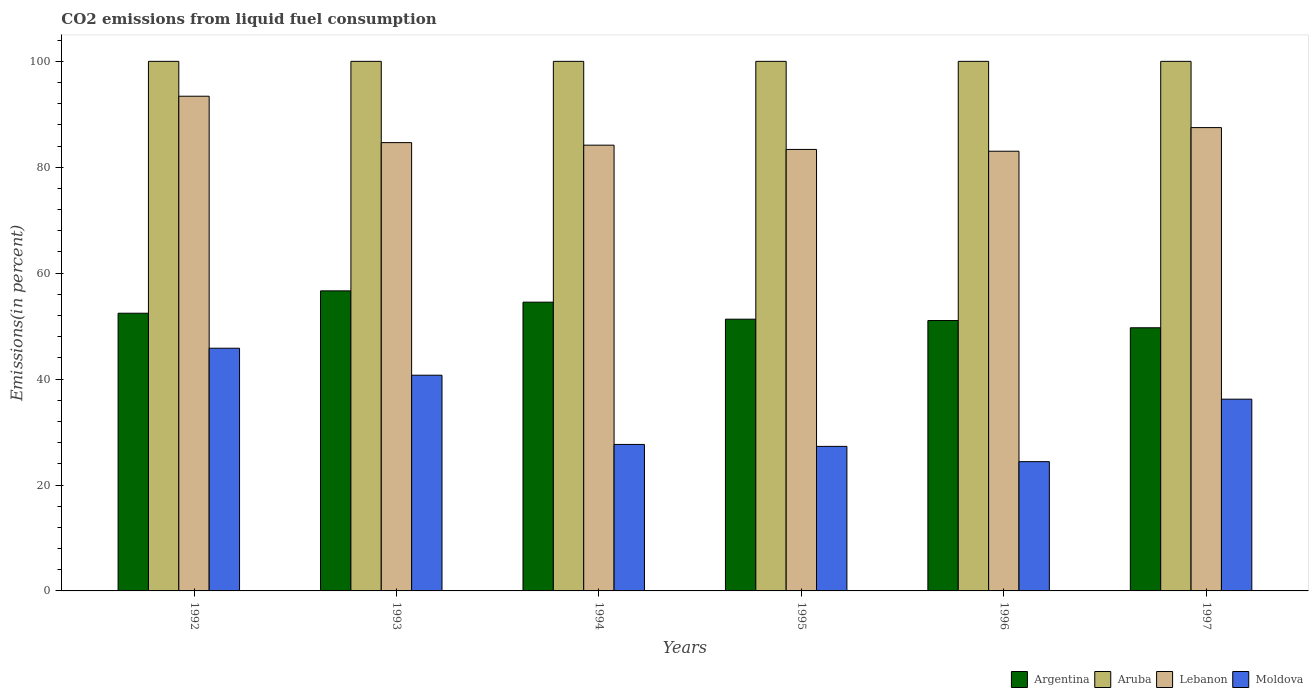How many different coloured bars are there?
Make the answer very short. 4. How many groups of bars are there?
Provide a short and direct response. 6. Are the number of bars per tick equal to the number of legend labels?
Your answer should be very brief. Yes. How many bars are there on the 1st tick from the left?
Provide a succinct answer. 4. How many bars are there on the 5th tick from the right?
Give a very brief answer. 4. What is the label of the 3rd group of bars from the left?
Offer a terse response. 1994. What is the total CO2 emitted in Argentina in 1992?
Your answer should be compact. 52.44. Across all years, what is the maximum total CO2 emitted in Argentina?
Offer a very short reply. 56.66. Across all years, what is the minimum total CO2 emitted in Lebanon?
Provide a short and direct response. 83.03. In which year was the total CO2 emitted in Moldova maximum?
Give a very brief answer. 1992. In which year was the total CO2 emitted in Argentina minimum?
Give a very brief answer. 1997. What is the total total CO2 emitted in Aruba in the graph?
Offer a very short reply. 600. What is the difference between the total CO2 emitted in Moldova in 1995 and that in 1996?
Your answer should be compact. 2.88. What is the difference between the total CO2 emitted in Argentina in 1996 and the total CO2 emitted in Aruba in 1994?
Your answer should be very brief. -48.94. What is the average total CO2 emitted in Lebanon per year?
Offer a terse response. 86.02. In the year 1997, what is the difference between the total CO2 emitted in Moldova and total CO2 emitted in Aruba?
Make the answer very short. -63.79. In how many years, is the total CO2 emitted in Aruba greater than 24 %?
Give a very brief answer. 6. What is the ratio of the total CO2 emitted in Moldova in 1995 to that in 1996?
Provide a succinct answer. 1.12. What is the difference between the highest and the second highest total CO2 emitted in Lebanon?
Your answer should be very brief. 5.92. What is the difference between the highest and the lowest total CO2 emitted in Moldova?
Provide a succinct answer. 21.42. What does the 3rd bar from the left in 1996 represents?
Provide a succinct answer. Lebanon. What does the 2nd bar from the right in 1997 represents?
Your answer should be very brief. Lebanon. How many years are there in the graph?
Make the answer very short. 6. Does the graph contain any zero values?
Keep it short and to the point. No. Where does the legend appear in the graph?
Your response must be concise. Bottom right. What is the title of the graph?
Keep it short and to the point. CO2 emissions from liquid fuel consumption. What is the label or title of the X-axis?
Your answer should be compact. Years. What is the label or title of the Y-axis?
Provide a short and direct response. Emissions(in percent). What is the Emissions(in percent) in Argentina in 1992?
Your answer should be very brief. 52.44. What is the Emissions(in percent) of Lebanon in 1992?
Make the answer very short. 93.42. What is the Emissions(in percent) in Moldova in 1992?
Provide a short and direct response. 45.83. What is the Emissions(in percent) of Argentina in 1993?
Offer a very short reply. 56.66. What is the Emissions(in percent) of Lebanon in 1993?
Your answer should be very brief. 84.65. What is the Emissions(in percent) of Moldova in 1993?
Make the answer very short. 40.73. What is the Emissions(in percent) of Argentina in 1994?
Give a very brief answer. 54.53. What is the Emissions(in percent) of Lebanon in 1994?
Give a very brief answer. 84.17. What is the Emissions(in percent) in Moldova in 1994?
Make the answer very short. 27.66. What is the Emissions(in percent) in Argentina in 1995?
Ensure brevity in your answer.  51.32. What is the Emissions(in percent) of Aruba in 1995?
Provide a succinct answer. 100. What is the Emissions(in percent) in Lebanon in 1995?
Your answer should be very brief. 83.37. What is the Emissions(in percent) in Moldova in 1995?
Offer a terse response. 27.29. What is the Emissions(in percent) of Argentina in 1996?
Offer a very short reply. 51.06. What is the Emissions(in percent) in Aruba in 1996?
Your response must be concise. 100. What is the Emissions(in percent) in Lebanon in 1996?
Your answer should be compact. 83.03. What is the Emissions(in percent) in Moldova in 1996?
Offer a very short reply. 24.41. What is the Emissions(in percent) of Argentina in 1997?
Offer a terse response. 49.69. What is the Emissions(in percent) in Aruba in 1997?
Offer a very short reply. 100. What is the Emissions(in percent) of Lebanon in 1997?
Make the answer very short. 87.49. What is the Emissions(in percent) in Moldova in 1997?
Your response must be concise. 36.21. Across all years, what is the maximum Emissions(in percent) of Argentina?
Offer a terse response. 56.66. Across all years, what is the maximum Emissions(in percent) of Lebanon?
Make the answer very short. 93.42. Across all years, what is the maximum Emissions(in percent) in Moldova?
Give a very brief answer. 45.83. Across all years, what is the minimum Emissions(in percent) in Argentina?
Your response must be concise. 49.69. Across all years, what is the minimum Emissions(in percent) in Lebanon?
Your answer should be very brief. 83.03. Across all years, what is the minimum Emissions(in percent) in Moldova?
Offer a terse response. 24.41. What is the total Emissions(in percent) in Argentina in the graph?
Provide a short and direct response. 315.69. What is the total Emissions(in percent) in Aruba in the graph?
Ensure brevity in your answer.  600. What is the total Emissions(in percent) in Lebanon in the graph?
Offer a terse response. 516.13. What is the total Emissions(in percent) of Moldova in the graph?
Offer a very short reply. 202.14. What is the difference between the Emissions(in percent) in Argentina in 1992 and that in 1993?
Offer a very short reply. -4.22. What is the difference between the Emissions(in percent) in Lebanon in 1992 and that in 1993?
Your answer should be very brief. 8.76. What is the difference between the Emissions(in percent) of Moldova in 1992 and that in 1993?
Your answer should be very brief. 5.1. What is the difference between the Emissions(in percent) in Argentina in 1992 and that in 1994?
Your answer should be very brief. -2.09. What is the difference between the Emissions(in percent) of Lebanon in 1992 and that in 1994?
Your answer should be very brief. 9.24. What is the difference between the Emissions(in percent) in Moldova in 1992 and that in 1994?
Your answer should be compact. 18.17. What is the difference between the Emissions(in percent) of Argentina in 1992 and that in 1995?
Offer a very short reply. 1.12. What is the difference between the Emissions(in percent) of Lebanon in 1992 and that in 1995?
Your answer should be compact. 10.05. What is the difference between the Emissions(in percent) in Moldova in 1992 and that in 1995?
Make the answer very short. 18.54. What is the difference between the Emissions(in percent) of Argentina in 1992 and that in 1996?
Provide a succinct answer. 1.38. What is the difference between the Emissions(in percent) in Aruba in 1992 and that in 1996?
Your answer should be compact. 0. What is the difference between the Emissions(in percent) of Lebanon in 1992 and that in 1996?
Provide a short and direct response. 10.39. What is the difference between the Emissions(in percent) in Moldova in 1992 and that in 1996?
Your response must be concise. 21.42. What is the difference between the Emissions(in percent) in Argentina in 1992 and that in 1997?
Offer a terse response. 2.75. What is the difference between the Emissions(in percent) of Aruba in 1992 and that in 1997?
Ensure brevity in your answer.  0. What is the difference between the Emissions(in percent) of Lebanon in 1992 and that in 1997?
Make the answer very short. 5.92. What is the difference between the Emissions(in percent) of Moldova in 1992 and that in 1997?
Ensure brevity in your answer.  9.62. What is the difference between the Emissions(in percent) in Argentina in 1993 and that in 1994?
Your response must be concise. 2.13. What is the difference between the Emissions(in percent) of Aruba in 1993 and that in 1994?
Provide a short and direct response. 0. What is the difference between the Emissions(in percent) of Lebanon in 1993 and that in 1994?
Your response must be concise. 0.48. What is the difference between the Emissions(in percent) of Moldova in 1993 and that in 1994?
Keep it short and to the point. 13.07. What is the difference between the Emissions(in percent) of Argentina in 1993 and that in 1995?
Keep it short and to the point. 5.35. What is the difference between the Emissions(in percent) of Aruba in 1993 and that in 1995?
Your answer should be compact. 0. What is the difference between the Emissions(in percent) in Lebanon in 1993 and that in 1995?
Your response must be concise. 1.28. What is the difference between the Emissions(in percent) in Moldova in 1993 and that in 1995?
Give a very brief answer. 13.44. What is the difference between the Emissions(in percent) of Argentina in 1993 and that in 1996?
Your answer should be very brief. 5.6. What is the difference between the Emissions(in percent) in Aruba in 1993 and that in 1996?
Provide a short and direct response. 0. What is the difference between the Emissions(in percent) of Lebanon in 1993 and that in 1996?
Give a very brief answer. 1.63. What is the difference between the Emissions(in percent) of Moldova in 1993 and that in 1996?
Keep it short and to the point. 16.32. What is the difference between the Emissions(in percent) of Argentina in 1993 and that in 1997?
Give a very brief answer. 6.97. What is the difference between the Emissions(in percent) in Aruba in 1993 and that in 1997?
Give a very brief answer. 0. What is the difference between the Emissions(in percent) in Lebanon in 1993 and that in 1997?
Your response must be concise. -2.84. What is the difference between the Emissions(in percent) in Moldova in 1993 and that in 1997?
Make the answer very short. 4.52. What is the difference between the Emissions(in percent) in Argentina in 1994 and that in 1995?
Offer a very short reply. 3.21. What is the difference between the Emissions(in percent) of Lebanon in 1994 and that in 1995?
Your answer should be compact. 0.8. What is the difference between the Emissions(in percent) of Moldova in 1994 and that in 1995?
Your answer should be very brief. 0.37. What is the difference between the Emissions(in percent) in Argentina in 1994 and that in 1996?
Make the answer very short. 3.47. What is the difference between the Emissions(in percent) of Aruba in 1994 and that in 1996?
Keep it short and to the point. 0. What is the difference between the Emissions(in percent) in Lebanon in 1994 and that in 1996?
Keep it short and to the point. 1.14. What is the difference between the Emissions(in percent) of Moldova in 1994 and that in 1996?
Give a very brief answer. 3.25. What is the difference between the Emissions(in percent) of Argentina in 1994 and that in 1997?
Your response must be concise. 4.84. What is the difference between the Emissions(in percent) in Aruba in 1994 and that in 1997?
Give a very brief answer. 0. What is the difference between the Emissions(in percent) in Lebanon in 1994 and that in 1997?
Offer a terse response. -3.32. What is the difference between the Emissions(in percent) in Moldova in 1994 and that in 1997?
Your answer should be very brief. -8.55. What is the difference between the Emissions(in percent) of Argentina in 1995 and that in 1996?
Ensure brevity in your answer.  0.26. What is the difference between the Emissions(in percent) of Lebanon in 1995 and that in 1996?
Offer a very short reply. 0.34. What is the difference between the Emissions(in percent) in Moldova in 1995 and that in 1996?
Make the answer very short. 2.88. What is the difference between the Emissions(in percent) in Argentina in 1995 and that in 1997?
Offer a very short reply. 1.62. What is the difference between the Emissions(in percent) of Aruba in 1995 and that in 1997?
Your answer should be very brief. 0. What is the difference between the Emissions(in percent) in Lebanon in 1995 and that in 1997?
Your answer should be compact. -4.12. What is the difference between the Emissions(in percent) of Moldova in 1995 and that in 1997?
Your answer should be compact. -8.92. What is the difference between the Emissions(in percent) in Argentina in 1996 and that in 1997?
Provide a succinct answer. 1.37. What is the difference between the Emissions(in percent) of Lebanon in 1996 and that in 1997?
Your response must be concise. -4.46. What is the difference between the Emissions(in percent) in Moldova in 1996 and that in 1997?
Your answer should be compact. -11.8. What is the difference between the Emissions(in percent) in Argentina in 1992 and the Emissions(in percent) in Aruba in 1993?
Give a very brief answer. -47.56. What is the difference between the Emissions(in percent) of Argentina in 1992 and the Emissions(in percent) of Lebanon in 1993?
Offer a terse response. -32.22. What is the difference between the Emissions(in percent) in Argentina in 1992 and the Emissions(in percent) in Moldova in 1993?
Your answer should be very brief. 11.71. What is the difference between the Emissions(in percent) in Aruba in 1992 and the Emissions(in percent) in Lebanon in 1993?
Make the answer very short. 15.35. What is the difference between the Emissions(in percent) in Aruba in 1992 and the Emissions(in percent) in Moldova in 1993?
Your answer should be compact. 59.27. What is the difference between the Emissions(in percent) in Lebanon in 1992 and the Emissions(in percent) in Moldova in 1993?
Your response must be concise. 52.68. What is the difference between the Emissions(in percent) of Argentina in 1992 and the Emissions(in percent) of Aruba in 1994?
Your answer should be compact. -47.56. What is the difference between the Emissions(in percent) of Argentina in 1992 and the Emissions(in percent) of Lebanon in 1994?
Provide a succinct answer. -31.73. What is the difference between the Emissions(in percent) in Argentina in 1992 and the Emissions(in percent) in Moldova in 1994?
Your response must be concise. 24.78. What is the difference between the Emissions(in percent) of Aruba in 1992 and the Emissions(in percent) of Lebanon in 1994?
Your answer should be very brief. 15.83. What is the difference between the Emissions(in percent) in Aruba in 1992 and the Emissions(in percent) in Moldova in 1994?
Your answer should be very brief. 72.34. What is the difference between the Emissions(in percent) in Lebanon in 1992 and the Emissions(in percent) in Moldova in 1994?
Your answer should be very brief. 65.75. What is the difference between the Emissions(in percent) of Argentina in 1992 and the Emissions(in percent) of Aruba in 1995?
Your response must be concise. -47.56. What is the difference between the Emissions(in percent) in Argentina in 1992 and the Emissions(in percent) in Lebanon in 1995?
Ensure brevity in your answer.  -30.93. What is the difference between the Emissions(in percent) of Argentina in 1992 and the Emissions(in percent) of Moldova in 1995?
Your answer should be very brief. 25.14. What is the difference between the Emissions(in percent) in Aruba in 1992 and the Emissions(in percent) in Lebanon in 1995?
Provide a short and direct response. 16.63. What is the difference between the Emissions(in percent) of Aruba in 1992 and the Emissions(in percent) of Moldova in 1995?
Make the answer very short. 72.71. What is the difference between the Emissions(in percent) of Lebanon in 1992 and the Emissions(in percent) of Moldova in 1995?
Provide a succinct answer. 66.12. What is the difference between the Emissions(in percent) in Argentina in 1992 and the Emissions(in percent) in Aruba in 1996?
Make the answer very short. -47.56. What is the difference between the Emissions(in percent) of Argentina in 1992 and the Emissions(in percent) of Lebanon in 1996?
Offer a terse response. -30.59. What is the difference between the Emissions(in percent) of Argentina in 1992 and the Emissions(in percent) of Moldova in 1996?
Provide a short and direct response. 28.03. What is the difference between the Emissions(in percent) of Aruba in 1992 and the Emissions(in percent) of Lebanon in 1996?
Give a very brief answer. 16.97. What is the difference between the Emissions(in percent) of Aruba in 1992 and the Emissions(in percent) of Moldova in 1996?
Give a very brief answer. 75.59. What is the difference between the Emissions(in percent) in Lebanon in 1992 and the Emissions(in percent) in Moldova in 1996?
Your answer should be compact. 69. What is the difference between the Emissions(in percent) of Argentina in 1992 and the Emissions(in percent) of Aruba in 1997?
Your response must be concise. -47.56. What is the difference between the Emissions(in percent) in Argentina in 1992 and the Emissions(in percent) in Lebanon in 1997?
Provide a short and direct response. -35.05. What is the difference between the Emissions(in percent) of Argentina in 1992 and the Emissions(in percent) of Moldova in 1997?
Keep it short and to the point. 16.23. What is the difference between the Emissions(in percent) in Aruba in 1992 and the Emissions(in percent) in Lebanon in 1997?
Offer a very short reply. 12.51. What is the difference between the Emissions(in percent) of Aruba in 1992 and the Emissions(in percent) of Moldova in 1997?
Offer a terse response. 63.79. What is the difference between the Emissions(in percent) in Lebanon in 1992 and the Emissions(in percent) in Moldova in 1997?
Ensure brevity in your answer.  57.21. What is the difference between the Emissions(in percent) of Argentina in 1993 and the Emissions(in percent) of Aruba in 1994?
Your answer should be very brief. -43.34. What is the difference between the Emissions(in percent) of Argentina in 1993 and the Emissions(in percent) of Lebanon in 1994?
Your answer should be compact. -27.51. What is the difference between the Emissions(in percent) in Argentina in 1993 and the Emissions(in percent) in Moldova in 1994?
Keep it short and to the point. 29. What is the difference between the Emissions(in percent) of Aruba in 1993 and the Emissions(in percent) of Lebanon in 1994?
Make the answer very short. 15.83. What is the difference between the Emissions(in percent) in Aruba in 1993 and the Emissions(in percent) in Moldova in 1994?
Make the answer very short. 72.34. What is the difference between the Emissions(in percent) of Lebanon in 1993 and the Emissions(in percent) of Moldova in 1994?
Provide a short and direct response. 56.99. What is the difference between the Emissions(in percent) of Argentina in 1993 and the Emissions(in percent) of Aruba in 1995?
Keep it short and to the point. -43.34. What is the difference between the Emissions(in percent) in Argentina in 1993 and the Emissions(in percent) in Lebanon in 1995?
Your answer should be compact. -26.71. What is the difference between the Emissions(in percent) in Argentina in 1993 and the Emissions(in percent) in Moldova in 1995?
Make the answer very short. 29.37. What is the difference between the Emissions(in percent) of Aruba in 1993 and the Emissions(in percent) of Lebanon in 1995?
Offer a very short reply. 16.63. What is the difference between the Emissions(in percent) of Aruba in 1993 and the Emissions(in percent) of Moldova in 1995?
Your response must be concise. 72.71. What is the difference between the Emissions(in percent) of Lebanon in 1993 and the Emissions(in percent) of Moldova in 1995?
Offer a terse response. 57.36. What is the difference between the Emissions(in percent) in Argentina in 1993 and the Emissions(in percent) in Aruba in 1996?
Your answer should be compact. -43.34. What is the difference between the Emissions(in percent) in Argentina in 1993 and the Emissions(in percent) in Lebanon in 1996?
Ensure brevity in your answer.  -26.37. What is the difference between the Emissions(in percent) of Argentina in 1993 and the Emissions(in percent) of Moldova in 1996?
Provide a succinct answer. 32.25. What is the difference between the Emissions(in percent) of Aruba in 1993 and the Emissions(in percent) of Lebanon in 1996?
Make the answer very short. 16.97. What is the difference between the Emissions(in percent) in Aruba in 1993 and the Emissions(in percent) in Moldova in 1996?
Your answer should be very brief. 75.59. What is the difference between the Emissions(in percent) in Lebanon in 1993 and the Emissions(in percent) in Moldova in 1996?
Make the answer very short. 60.24. What is the difference between the Emissions(in percent) in Argentina in 1993 and the Emissions(in percent) in Aruba in 1997?
Provide a short and direct response. -43.34. What is the difference between the Emissions(in percent) of Argentina in 1993 and the Emissions(in percent) of Lebanon in 1997?
Offer a very short reply. -30.83. What is the difference between the Emissions(in percent) of Argentina in 1993 and the Emissions(in percent) of Moldova in 1997?
Give a very brief answer. 20.45. What is the difference between the Emissions(in percent) in Aruba in 1993 and the Emissions(in percent) in Lebanon in 1997?
Provide a short and direct response. 12.51. What is the difference between the Emissions(in percent) of Aruba in 1993 and the Emissions(in percent) of Moldova in 1997?
Provide a succinct answer. 63.79. What is the difference between the Emissions(in percent) in Lebanon in 1993 and the Emissions(in percent) in Moldova in 1997?
Your response must be concise. 48.45. What is the difference between the Emissions(in percent) in Argentina in 1994 and the Emissions(in percent) in Aruba in 1995?
Your response must be concise. -45.47. What is the difference between the Emissions(in percent) in Argentina in 1994 and the Emissions(in percent) in Lebanon in 1995?
Provide a succinct answer. -28.84. What is the difference between the Emissions(in percent) in Argentina in 1994 and the Emissions(in percent) in Moldova in 1995?
Provide a succinct answer. 27.23. What is the difference between the Emissions(in percent) of Aruba in 1994 and the Emissions(in percent) of Lebanon in 1995?
Your answer should be compact. 16.63. What is the difference between the Emissions(in percent) of Aruba in 1994 and the Emissions(in percent) of Moldova in 1995?
Provide a succinct answer. 72.71. What is the difference between the Emissions(in percent) of Lebanon in 1994 and the Emissions(in percent) of Moldova in 1995?
Provide a succinct answer. 56.88. What is the difference between the Emissions(in percent) of Argentina in 1994 and the Emissions(in percent) of Aruba in 1996?
Keep it short and to the point. -45.47. What is the difference between the Emissions(in percent) of Argentina in 1994 and the Emissions(in percent) of Lebanon in 1996?
Ensure brevity in your answer.  -28.5. What is the difference between the Emissions(in percent) of Argentina in 1994 and the Emissions(in percent) of Moldova in 1996?
Ensure brevity in your answer.  30.12. What is the difference between the Emissions(in percent) in Aruba in 1994 and the Emissions(in percent) in Lebanon in 1996?
Keep it short and to the point. 16.97. What is the difference between the Emissions(in percent) in Aruba in 1994 and the Emissions(in percent) in Moldova in 1996?
Provide a succinct answer. 75.59. What is the difference between the Emissions(in percent) of Lebanon in 1994 and the Emissions(in percent) of Moldova in 1996?
Your response must be concise. 59.76. What is the difference between the Emissions(in percent) of Argentina in 1994 and the Emissions(in percent) of Aruba in 1997?
Your response must be concise. -45.47. What is the difference between the Emissions(in percent) in Argentina in 1994 and the Emissions(in percent) in Lebanon in 1997?
Keep it short and to the point. -32.96. What is the difference between the Emissions(in percent) of Argentina in 1994 and the Emissions(in percent) of Moldova in 1997?
Keep it short and to the point. 18.32. What is the difference between the Emissions(in percent) of Aruba in 1994 and the Emissions(in percent) of Lebanon in 1997?
Ensure brevity in your answer.  12.51. What is the difference between the Emissions(in percent) of Aruba in 1994 and the Emissions(in percent) of Moldova in 1997?
Offer a very short reply. 63.79. What is the difference between the Emissions(in percent) of Lebanon in 1994 and the Emissions(in percent) of Moldova in 1997?
Keep it short and to the point. 47.96. What is the difference between the Emissions(in percent) of Argentina in 1995 and the Emissions(in percent) of Aruba in 1996?
Keep it short and to the point. -48.68. What is the difference between the Emissions(in percent) in Argentina in 1995 and the Emissions(in percent) in Lebanon in 1996?
Provide a succinct answer. -31.71. What is the difference between the Emissions(in percent) of Argentina in 1995 and the Emissions(in percent) of Moldova in 1996?
Provide a succinct answer. 26.9. What is the difference between the Emissions(in percent) in Aruba in 1995 and the Emissions(in percent) in Lebanon in 1996?
Make the answer very short. 16.97. What is the difference between the Emissions(in percent) of Aruba in 1995 and the Emissions(in percent) of Moldova in 1996?
Your answer should be very brief. 75.59. What is the difference between the Emissions(in percent) in Lebanon in 1995 and the Emissions(in percent) in Moldova in 1996?
Give a very brief answer. 58.96. What is the difference between the Emissions(in percent) of Argentina in 1995 and the Emissions(in percent) of Aruba in 1997?
Offer a terse response. -48.68. What is the difference between the Emissions(in percent) in Argentina in 1995 and the Emissions(in percent) in Lebanon in 1997?
Keep it short and to the point. -36.18. What is the difference between the Emissions(in percent) in Argentina in 1995 and the Emissions(in percent) in Moldova in 1997?
Give a very brief answer. 15.11. What is the difference between the Emissions(in percent) of Aruba in 1995 and the Emissions(in percent) of Lebanon in 1997?
Make the answer very short. 12.51. What is the difference between the Emissions(in percent) of Aruba in 1995 and the Emissions(in percent) of Moldova in 1997?
Offer a terse response. 63.79. What is the difference between the Emissions(in percent) in Lebanon in 1995 and the Emissions(in percent) in Moldova in 1997?
Ensure brevity in your answer.  47.16. What is the difference between the Emissions(in percent) of Argentina in 1996 and the Emissions(in percent) of Aruba in 1997?
Your response must be concise. -48.94. What is the difference between the Emissions(in percent) in Argentina in 1996 and the Emissions(in percent) in Lebanon in 1997?
Make the answer very short. -36.43. What is the difference between the Emissions(in percent) in Argentina in 1996 and the Emissions(in percent) in Moldova in 1997?
Offer a very short reply. 14.85. What is the difference between the Emissions(in percent) of Aruba in 1996 and the Emissions(in percent) of Lebanon in 1997?
Your response must be concise. 12.51. What is the difference between the Emissions(in percent) of Aruba in 1996 and the Emissions(in percent) of Moldova in 1997?
Make the answer very short. 63.79. What is the difference between the Emissions(in percent) in Lebanon in 1996 and the Emissions(in percent) in Moldova in 1997?
Give a very brief answer. 46.82. What is the average Emissions(in percent) in Argentina per year?
Offer a terse response. 52.62. What is the average Emissions(in percent) in Aruba per year?
Your response must be concise. 100. What is the average Emissions(in percent) in Lebanon per year?
Give a very brief answer. 86.02. What is the average Emissions(in percent) in Moldova per year?
Provide a succinct answer. 33.69. In the year 1992, what is the difference between the Emissions(in percent) in Argentina and Emissions(in percent) in Aruba?
Give a very brief answer. -47.56. In the year 1992, what is the difference between the Emissions(in percent) of Argentina and Emissions(in percent) of Lebanon?
Make the answer very short. -40.98. In the year 1992, what is the difference between the Emissions(in percent) in Argentina and Emissions(in percent) in Moldova?
Provide a short and direct response. 6.61. In the year 1992, what is the difference between the Emissions(in percent) in Aruba and Emissions(in percent) in Lebanon?
Keep it short and to the point. 6.58. In the year 1992, what is the difference between the Emissions(in percent) in Aruba and Emissions(in percent) in Moldova?
Your answer should be very brief. 54.17. In the year 1992, what is the difference between the Emissions(in percent) of Lebanon and Emissions(in percent) of Moldova?
Provide a short and direct response. 47.59. In the year 1993, what is the difference between the Emissions(in percent) of Argentina and Emissions(in percent) of Aruba?
Provide a succinct answer. -43.34. In the year 1993, what is the difference between the Emissions(in percent) of Argentina and Emissions(in percent) of Lebanon?
Your answer should be compact. -27.99. In the year 1993, what is the difference between the Emissions(in percent) of Argentina and Emissions(in percent) of Moldova?
Keep it short and to the point. 15.93. In the year 1993, what is the difference between the Emissions(in percent) of Aruba and Emissions(in percent) of Lebanon?
Offer a terse response. 15.35. In the year 1993, what is the difference between the Emissions(in percent) of Aruba and Emissions(in percent) of Moldova?
Offer a terse response. 59.27. In the year 1993, what is the difference between the Emissions(in percent) in Lebanon and Emissions(in percent) in Moldova?
Provide a short and direct response. 43.92. In the year 1994, what is the difference between the Emissions(in percent) in Argentina and Emissions(in percent) in Aruba?
Provide a succinct answer. -45.47. In the year 1994, what is the difference between the Emissions(in percent) in Argentina and Emissions(in percent) in Lebanon?
Offer a terse response. -29.64. In the year 1994, what is the difference between the Emissions(in percent) in Argentina and Emissions(in percent) in Moldova?
Provide a succinct answer. 26.87. In the year 1994, what is the difference between the Emissions(in percent) in Aruba and Emissions(in percent) in Lebanon?
Make the answer very short. 15.83. In the year 1994, what is the difference between the Emissions(in percent) in Aruba and Emissions(in percent) in Moldova?
Your answer should be compact. 72.34. In the year 1994, what is the difference between the Emissions(in percent) of Lebanon and Emissions(in percent) of Moldova?
Give a very brief answer. 56.51. In the year 1995, what is the difference between the Emissions(in percent) in Argentina and Emissions(in percent) in Aruba?
Ensure brevity in your answer.  -48.68. In the year 1995, what is the difference between the Emissions(in percent) of Argentina and Emissions(in percent) of Lebanon?
Provide a short and direct response. -32.05. In the year 1995, what is the difference between the Emissions(in percent) in Argentina and Emissions(in percent) in Moldova?
Give a very brief answer. 24.02. In the year 1995, what is the difference between the Emissions(in percent) of Aruba and Emissions(in percent) of Lebanon?
Your response must be concise. 16.63. In the year 1995, what is the difference between the Emissions(in percent) of Aruba and Emissions(in percent) of Moldova?
Ensure brevity in your answer.  72.71. In the year 1995, what is the difference between the Emissions(in percent) of Lebanon and Emissions(in percent) of Moldova?
Give a very brief answer. 56.08. In the year 1996, what is the difference between the Emissions(in percent) of Argentina and Emissions(in percent) of Aruba?
Provide a succinct answer. -48.94. In the year 1996, what is the difference between the Emissions(in percent) of Argentina and Emissions(in percent) of Lebanon?
Ensure brevity in your answer.  -31.97. In the year 1996, what is the difference between the Emissions(in percent) in Argentina and Emissions(in percent) in Moldova?
Provide a short and direct response. 26.65. In the year 1996, what is the difference between the Emissions(in percent) in Aruba and Emissions(in percent) in Lebanon?
Offer a very short reply. 16.97. In the year 1996, what is the difference between the Emissions(in percent) of Aruba and Emissions(in percent) of Moldova?
Offer a very short reply. 75.59. In the year 1996, what is the difference between the Emissions(in percent) of Lebanon and Emissions(in percent) of Moldova?
Your response must be concise. 58.62. In the year 1997, what is the difference between the Emissions(in percent) in Argentina and Emissions(in percent) in Aruba?
Provide a short and direct response. -50.31. In the year 1997, what is the difference between the Emissions(in percent) of Argentina and Emissions(in percent) of Lebanon?
Ensure brevity in your answer.  -37.8. In the year 1997, what is the difference between the Emissions(in percent) in Argentina and Emissions(in percent) in Moldova?
Offer a terse response. 13.48. In the year 1997, what is the difference between the Emissions(in percent) in Aruba and Emissions(in percent) in Lebanon?
Provide a short and direct response. 12.51. In the year 1997, what is the difference between the Emissions(in percent) of Aruba and Emissions(in percent) of Moldova?
Give a very brief answer. 63.79. In the year 1997, what is the difference between the Emissions(in percent) of Lebanon and Emissions(in percent) of Moldova?
Your response must be concise. 51.28. What is the ratio of the Emissions(in percent) of Argentina in 1992 to that in 1993?
Keep it short and to the point. 0.93. What is the ratio of the Emissions(in percent) of Lebanon in 1992 to that in 1993?
Your answer should be very brief. 1.1. What is the ratio of the Emissions(in percent) of Moldova in 1992 to that in 1993?
Offer a very short reply. 1.13. What is the ratio of the Emissions(in percent) in Argentina in 1992 to that in 1994?
Offer a terse response. 0.96. What is the ratio of the Emissions(in percent) in Lebanon in 1992 to that in 1994?
Your answer should be very brief. 1.11. What is the ratio of the Emissions(in percent) in Moldova in 1992 to that in 1994?
Your response must be concise. 1.66. What is the ratio of the Emissions(in percent) of Argentina in 1992 to that in 1995?
Your answer should be compact. 1.02. What is the ratio of the Emissions(in percent) in Lebanon in 1992 to that in 1995?
Offer a terse response. 1.12. What is the ratio of the Emissions(in percent) of Moldova in 1992 to that in 1995?
Give a very brief answer. 1.68. What is the ratio of the Emissions(in percent) in Lebanon in 1992 to that in 1996?
Offer a very short reply. 1.13. What is the ratio of the Emissions(in percent) of Moldova in 1992 to that in 1996?
Provide a succinct answer. 1.88. What is the ratio of the Emissions(in percent) of Argentina in 1992 to that in 1997?
Offer a terse response. 1.06. What is the ratio of the Emissions(in percent) in Aruba in 1992 to that in 1997?
Give a very brief answer. 1. What is the ratio of the Emissions(in percent) of Lebanon in 1992 to that in 1997?
Give a very brief answer. 1.07. What is the ratio of the Emissions(in percent) of Moldova in 1992 to that in 1997?
Make the answer very short. 1.27. What is the ratio of the Emissions(in percent) in Argentina in 1993 to that in 1994?
Offer a terse response. 1.04. What is the ratio of the Emissions(in percent) in Aruba in 1993 to that in 1994?
Your response must be concise. 1. What is the ratio of the Emissions(in percent) of Lebanon in 1993 to that in 1994?
Provide a succinct answer. 1.01. What is the ratio of the Emissions(in percent) in Moldova in 1993 to that in 1994?
Provide a short and direct response. 1.47. What is the ratio of the Emissions(in percent) in Argentina in 1993 to that in 1995?
Make the answer very short. 1.1. What is the ratio of the Emissions(in percent) in Aruba in 1993 to that in 1995?
Provide a short and direct response. 1. What is the ratio of the Emissions(in percent) of Lebanon in 1993 to that in 1995?
Offer a very short reply. 1.02. What is the ratio of the Emissions(in percent) in Moldova in 1993 to that in 1995?
Make the answer very short. 1.49. What is the ratio of the Emissions(in percent) of Argentina in 1993 to that in 1996?
Provide a short and direct response. 1.11. What is the ratio of the Emissions(in percent) of Lebanon in 1993 to that in 1996?
Provide a short and direct response. 1.02. What is the ratio of the Emissions(in percent) in Moldova in 1993 to that in 1996?
Ensure brevity in your answer.  1.67. What is the ratio of the Emissions(in percent) of Argentina in 1993 to that in 1997?
Make the answer very short. 1.14. What is the ratio of the Emissions(in percent) in Aruba in 1993 to that in 1997?
Provide a short and direct response. 1. What is the ratio of the Emissions(in percent) in Lebanon in 1993 to that in 1997?
Offer a very short reply. 0.97. What is the ratio of the Emissions(in percent) in Moldova in 1993 to that in 1997?
Make the answer very short. 1.12. What is the ratio of the Emissions(in percent) in Argentina in 1994 to that in 1995?
Your answer should be very brief. 1.06. What is the ratio of the Emissions(in percent) of Aruba in 1994 to that in 1995?
Ensure brevity in your answer.  1. What is the ratio of the Emissions(in percent) of Lebanon in 1994 to that in 1995?
Your response must be concise. 1.01. What is the ratio of the Emissions(in percent) in Moldova in 1994 to that in 1995?
Offer a terse response. 1.01. What is the ratio of the Emissions(in percent) of Argentina in 1994 to that in 1996?
Keep it short and to the point. 1.07. What is the ratio of the Emissions(in percent) of Aruba in 1994 to that in 1996?
Offer a terse response. 1. What is the ratio of the Emissions(in percent) of Lebanon in 1994 to that in 1996?
Offer a very short reply. 1.01. What is the ratio of the Emissions(in percent) in Moldova in 1994 to that in 1996?
Your response must be concise. 1.13. What is the ratio of the Emissions(in percent) in Argentina in 1994 to that in 1997?
Provide a succinct answer. 1.1. What is the ratio of the Emissions(in percent) of Lebanon in 1994 to that in 1997?
Your answer should be very brief. 0.96. What is the ratio of the Emissions(in percent) of Moldova in 1994 to that in 1997?
Your answer should be very brief. 0.76. What is the ratio of the Emissions(in percent) in Aruba in 1995 to that in 1996?
Your answer should be very brief. 1. What is the ratio of the Emissions(in percent) of Lebanon in 1995 to that in 1996?
Provide a short and direct response. 1. What is the ratio of the Emissions(in percent) in Moldova in 1995 to that in 1996?
Provide a succinct answer. 1.12. What is the ratio of the Emissions(in percent) of Argentina in 1995 to that in 1997?
Provide a succinct answer. 1.03. What is the ratio of the Emissions(in percent) in Lebanon in 1995 to that in 1997?
Your answer should be very brief. 0.95. What is the ratio of the Emissions(in percent) in Moldova in 1995 to that in 1997?
Give a very brief answer. 0.75. What is the ratio of the Emissions(in percent) of Argentina in 1996 to that in 1997?
Keep it short and to the point. 1.03. What is the ratio of the Emissions(in percent) of Aruba in 1996 to that in 1997?
Make the answer very short. 1. What is the ratio of the Emissions(in percent) of Lebanon in 1996 to that in 1997?
Your answer should be very brief. 0.95. What is the ratio of the Emissions(in percent) in Moldova in 1996 to that in 1997?
Offer a terse response. 0.67. What is the difference between the highest and the second highest Emissions(in percent) in Argentina?
Your answer should be compact. 2.13. What is the difference between the highest and the second highest Emissions(in percent) of Aruba?
Ensure brevity in your answer.  0. What is the difference between the highest and the second highest Emissions(in percent) in Lebanon?
Provide a succinct answer. 5.92. What is the difference between the highest and the second highest Emissions(in percent) of Moldova?
Offer a very short reply. 5.1. What is the difference between the highest and the lowest Emissions(in percent) in Argentina?
Provide a short and direct response. 6.97. What is the difference between the highest and the lowest Emissions(in percent) of Lebanon?
Provide a succinct answer. 10.39. What is the difference between the highest and the lowest Emissions(in percent) in Moldova?
Offer a very short reply. 21.42. 